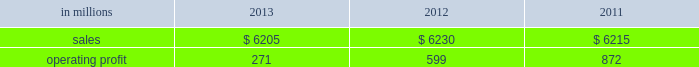Million excluding a gain on a bargain purchase price adjustment on the acquisition of a majority share of our operations in turkey and restructuring costs ) compared with $ 53 million ( $ 72 million excluding restructuring costs ) in 2012 and $ 66 million ( $ 61 million excluding a gain for a bargain purchase price adjustment on an acquisition by our then joint venture in turkey and costs associated with the closure of our etienne mill in france in 2009 ) in 2011 .
Sales volumes in 2013 were higher than in 2012 reflecting strong demand for packaging in the agricultural markets in morocco and turkey .
In europe , sales volumes decreased slightly due to continuing weak demand for packaging in the industrial markets , and lower demand for packaging in the agricultural markets resulting from poor weather conditions .
Average sales margins were significantly lower due to input costs for containerboard rising ahead of box sales price increases .
Other input costs were also higher , primarily for energy .
Operating profits in 2013 and 2012 included net gains of $ 13 million and $ 10 million , respectively , for insurance settlements and italian government grants , partially offset by additional operating costs , related to the earthquakes in northern italy in may 2012 which affected our san felice box plant .
Entering the first quarter of 2014 , sales volumes are expected to increase slightly reflecting higher demand for packaging in the industrial markets .
Average sales margins are expected to gradually improve as a result of slight reductions in material costs and planned box price increases .
Other input costs should be about flat .
Brazilian industrial packaging includes the results of orsa international paper embalagens s.a. , a corrugated packaging producer in which international paper acquired a 75% ( 75 % ) share in january 2013 .
Net sales were $ 335 million in 2013 .
Operating profits in 2013 were a loss of $ 2 million ( a gain of $ 2 million excluding acquisition and integration costs ) .
Looking ahead to the first quarter of 2014 , sales volumes are expected to be seasonally lower than in the fourth quarter of 2013 .
Average sales margins should improve reflecting the partial implementation of an announced sales price increase and a more favorable product mix .
Operating costs and input costs are expected to be lower .
Asian industrial packaging net sales were $ 400 million in 2013 compared with $ 400 million in 2012 and $ 410 million in 2011 .
Operating profits for the packaging operations were a loss of $ 5 million in 2013 ( a loss of $ 1 million excluding restructuring costs ) compared with gains of $ 2 million in 2012 and $ 2 million in 2011 .
Operating profits were favorably impacted in 2013 by higher average sales margins and slightly higher sales volumes compared with 2012 , but these benefits were offset by higher operating costs .
Looking ahead to the first quarter of 2014 , sales volumes and average sales margins are expected to be seasonally soft .
Net sales for the distribution operations were $ 285 million in 2013 compared with $ 260 million in 2012 and $ 285 million in 2011 .
Operating profits were $ 3 million in 2013 , 2012 and 2011 .
Printing papers demand for printing papers products is closely correlated with changes in commercial printing and advertising activity , direct mail volumes and , for uncoated cut-size products , with changes in white- collar employment levels that affect the usage of copy and laser printer paper .
Pulp is further affected by changes in currency rates that can enhance or disadvantage producers in different geographic regions .
Principal cost drivers include manufacturing efficiency , raw material and energy costs and freight costs .
Printing papers net sales for 2013 were about flat with both 2012 and 2011 .
Operating profits in 2013 were 55% ( 55 % ) lower than in 2012 and 69% ( 69 % ) lower than in 2011 .
Excluding facility closure costs and impairment costs , operating profits in 2013 were 15% ( 15 % ) lower than in 2012 and 40% ( 40 % ) lower than in 2011 .
Benefits from lower operating costs ( $ 81 million ) and lower maintenance outage costs ( $ 17 million ) were more than offset by lower average sales price realizations ( $ 38 million ) , lower sales volumes ( $ 14 million ) , higher input costs ( $ 99 million ) and higher other costs ( $ 34 million ) .
In addition , operating profits in 2013 included costs of $ 118 million associated with the announced closure of our courtland , alabama mill .
During 2013 , the company accelerated depreciation for certain courtland assets , and diligently evaluated certain other assets for possible alternative uses by one of our other businesses .
The net book value of these assets at december 31 , 2013 was approximately $ 470 million .
During 2014 , we have continued our evaluation and expect to conclude as to any uses for these assets during the first quarter of 2014 .
Operating profits also included a $ 123 million impairment charge associated with goodwill and a trade name intangible asset in our india papers business .
Operating profits in 2011 included a $ 24 million gain related to the announced repurposing of our franklin , virginia mill to produce fluff pulp and an $ 11 million impairment charge related to our inverurie , scotland mill that was closed in 2009 .
Printing papers .
North american printing papers net sales were $ 2.6 billion in 2013 , $ 2.7 billion in 2012 and $ 2.8 billion in 2011. .
What was the cumulative asian industrial packaging net sales from 2011 to 2013? 
Computations: (410 + (400 + 400))
Answer: 1210.0. 